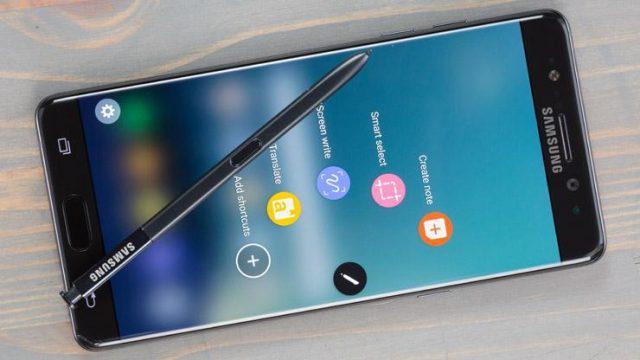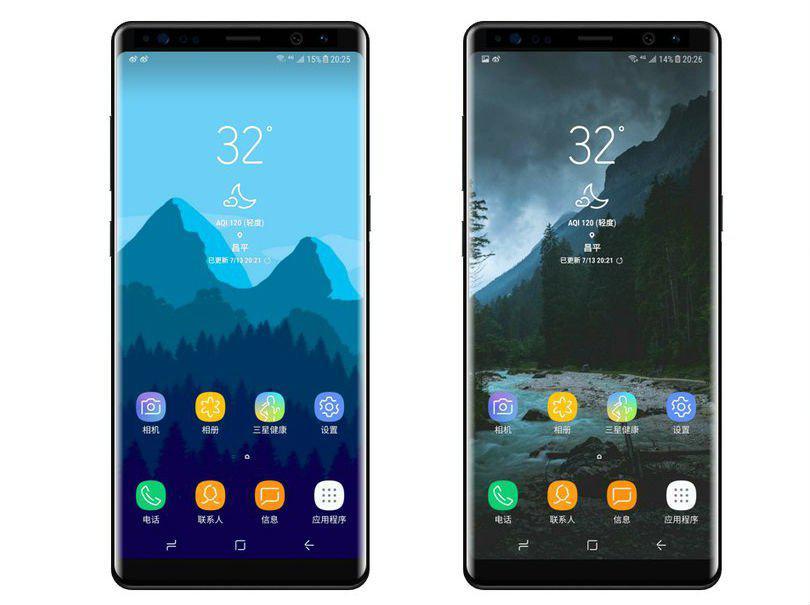The first image is the image on the left, the second image is the image on the right. Analyze the images presented: Is the assertion "The back of a phone is visible." valid? Answer yes or no. No. The first image is the image on the left, the second image is the image on the right. Considering the images on both sides, is "The image on the left shows one smartphone, face up on a wood table." valid? Answer yes or no. Yes. 